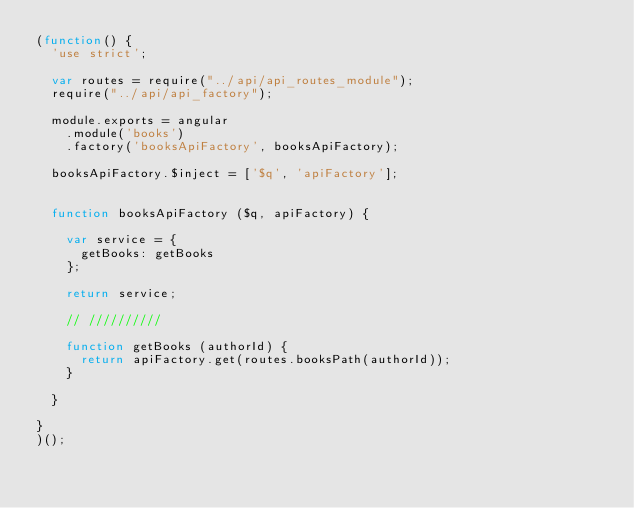Convert code to text. <code><loc_0><loc_0><loc_500><loc_500><_JavaScript_>(function() {
  'use strict';

  var routes = require("../api/api_routes_module");
  require("../api/api_factory");

  module.exports = angular
    .module('books')
    .factory('booksApiFactory', booksApiFactory);

  booksApiFactory.$inject = ['$q', 'apiFactory'];


  function booksApiFactory ($q, apiFactory) {

    var service = {
      getBooks: getBooks
    };

    return service;

    // //////////

    function getBooks (authorId) {
      return apiFactory.get(routes.booksPath(authorId));
    }

  }

}
)();
</code> 